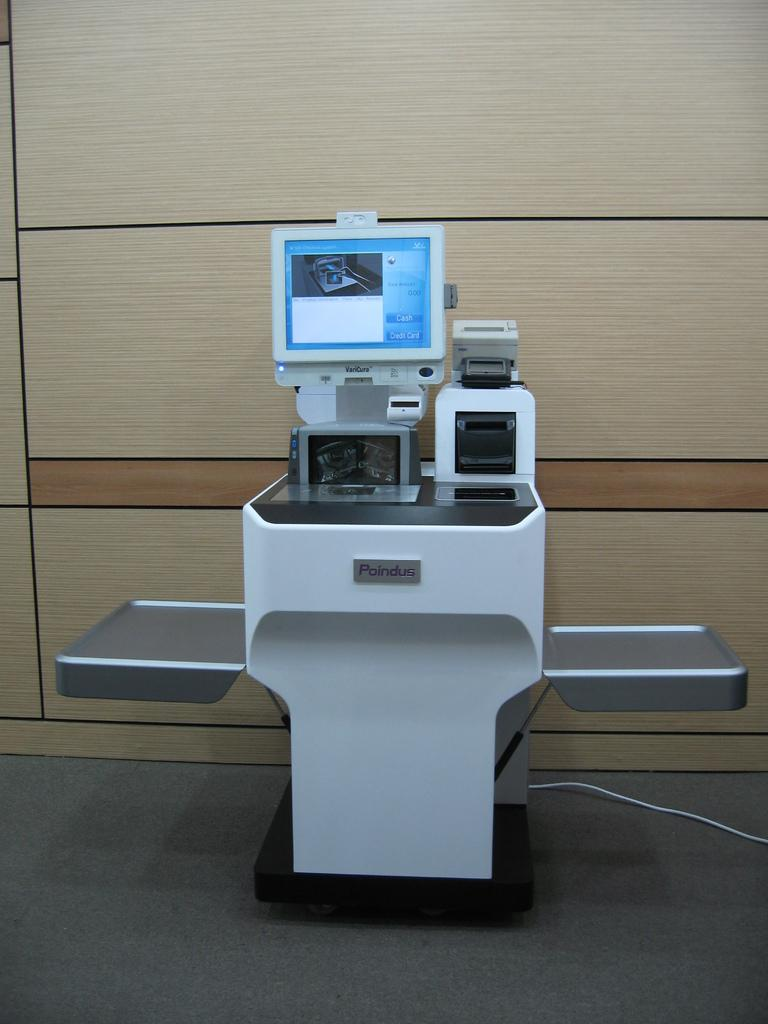What type of wall can be seen in the background of the image? There is a wooden wall in the background of the image. What object is present in the image? There is a machine in the image. What is on the floor carpet in the image? There is a wire on the floor carpet in the image. What type of secretary is sitting next to the machine in the image? There is no secretary present in the image; it only features a wooden wall, a machine, and a wire on the floor carpet. How does the machine aid in the digestion process in the image? The image does not depict any digestion process, nor does it show a machine that aids in digestion. 